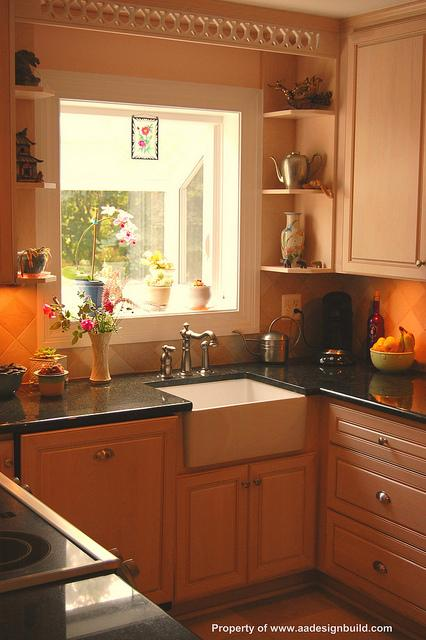What is the type of stove cooktop called?

Choices:
A) induction
B) gas
C) electric
D) propane electric 